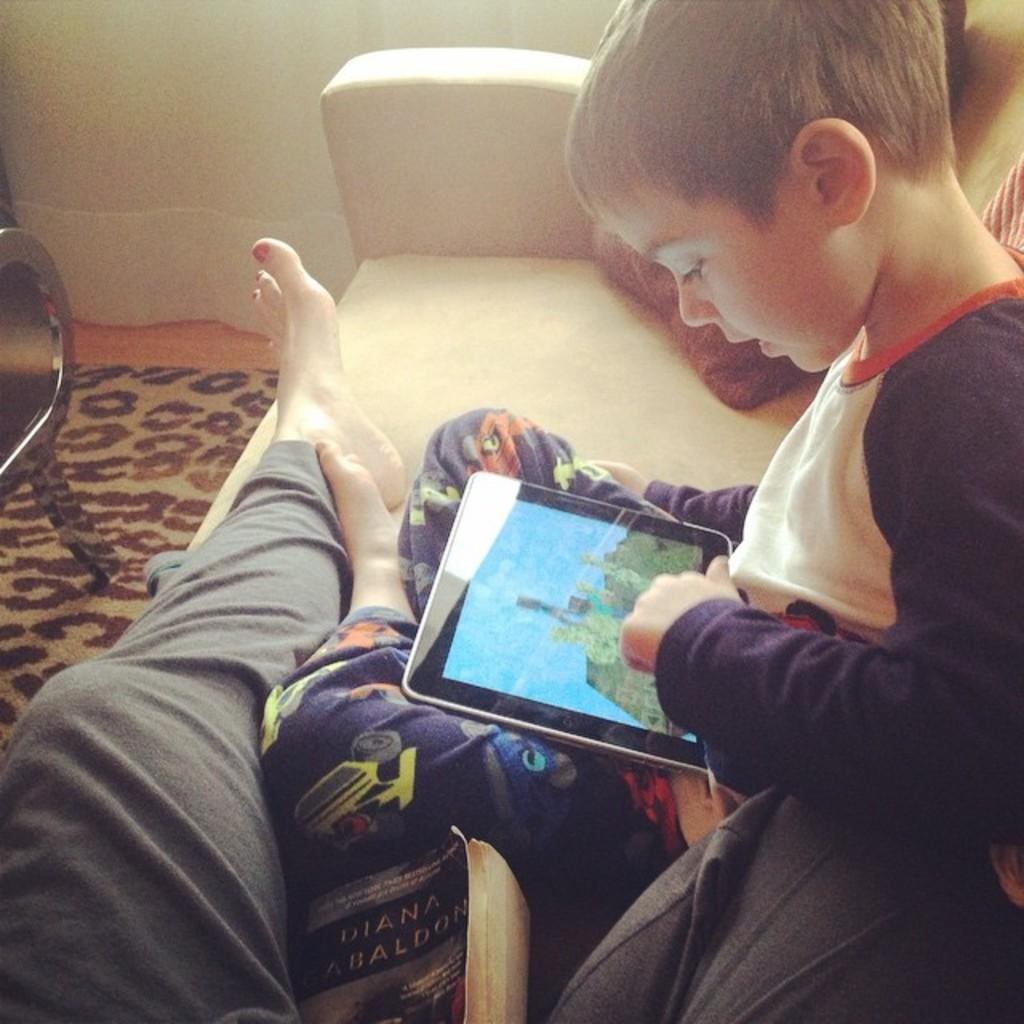What is the boy in the image doing? The boy is sitting on a couch and playing a video game on an electronic gadget. Can you describe the position of the other person in the image? There is a person lying on a couch in the image. What object related to reading can be seen in the image? There is a book in the image. What type of furniture is present in the image besides the couch? There is a chair in the image. What type of window treatment is visible in the image? There is a curtain in the image. What type of alarm is the boy using to play the video game in the image? There is no alarm present in the image; the boy is playing a video game on an electronic gadget. Can you describe the type of vessel used by the person lying on the couch in the image? There is no vessel present in the image; the person lying on the couch is not using any vessel. 